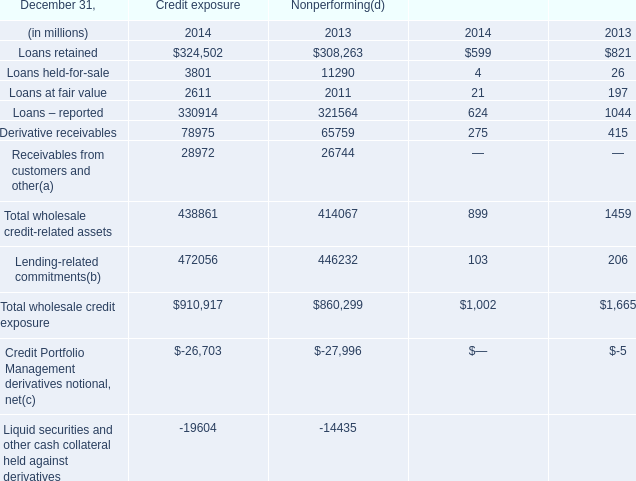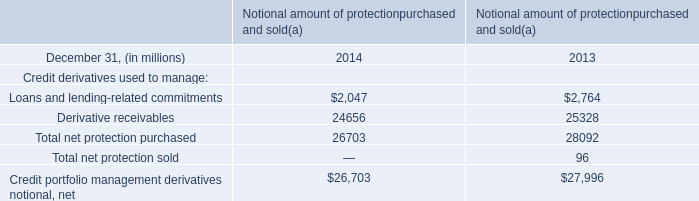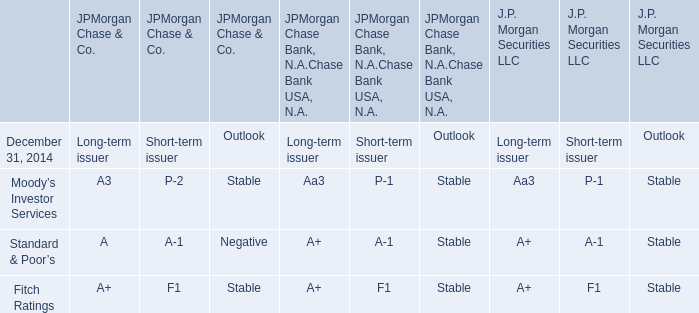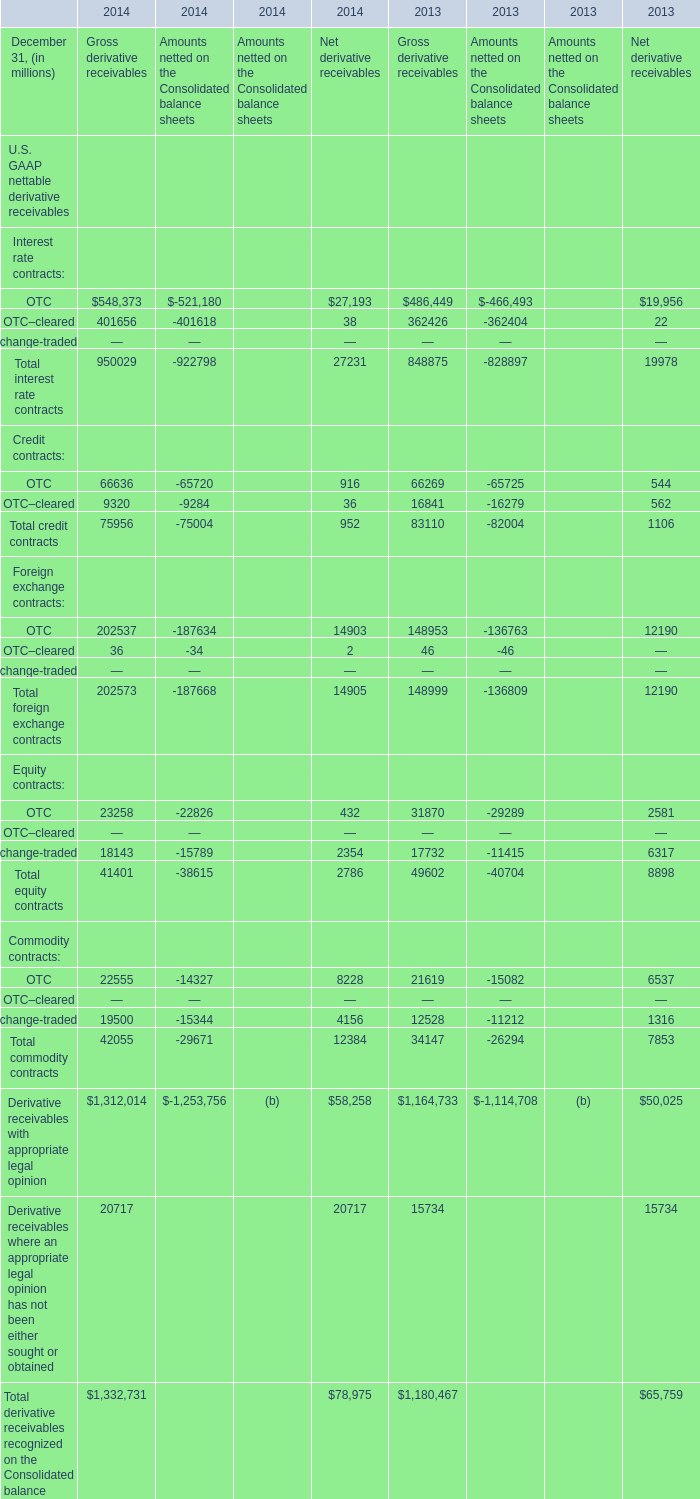What is the sum of OTC in the range of 1 and 1000000 in 2014? (in million) 
Computations: (916 + 66636)
Answer: 67552.0. 